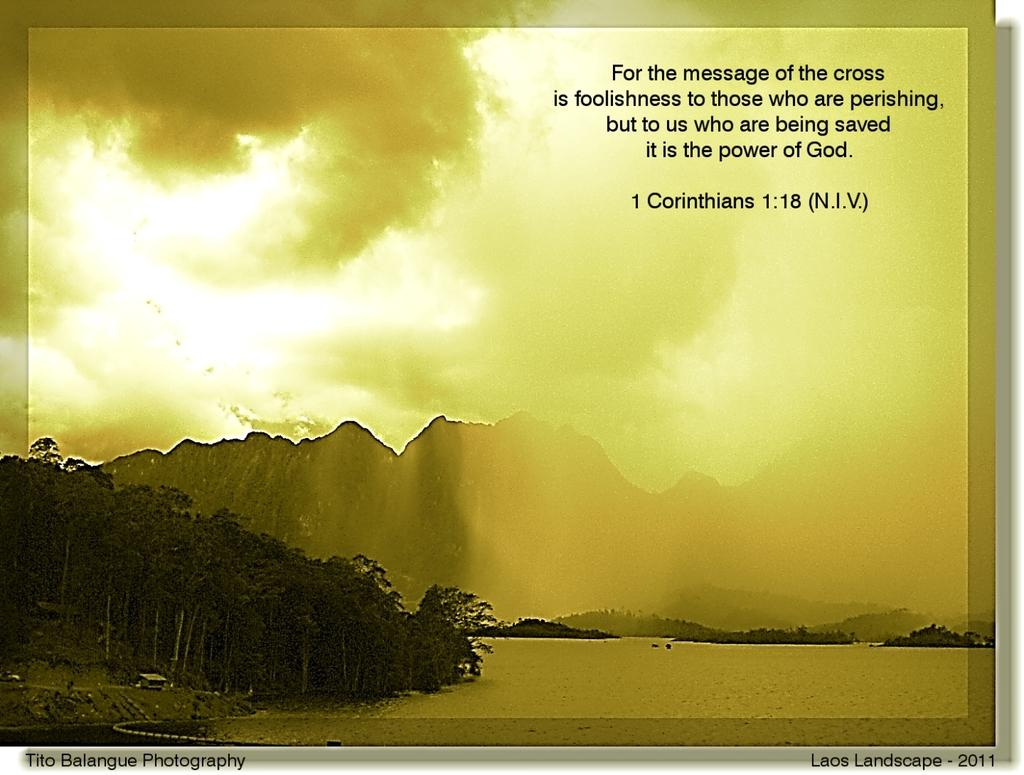Provide a one-sentence caption for the provided image. A photograph taken by Tito Balangue Photography called Laos Landscape 2011. 